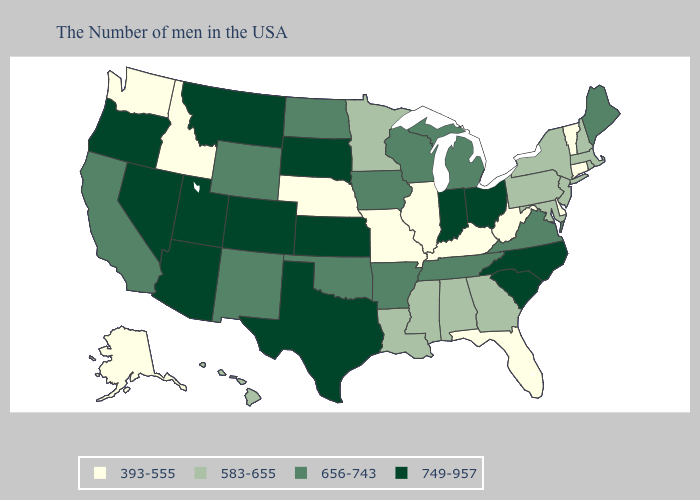How many symbols are there in the legend?
Quick response, please. 4. What is the lowest value in the Northeast?
Be succinct. 393-555. What is the value of South Dakota?
Write a very short answer. 749-957. Which states have the lowest value in the USA?
Concise answer only. Vermont, Connecticut, Delaware, West Virginia, Florida, Kentucky, Illinois, Missouri, Nebraska, Idaho, Washington, Alaska. Does Montana have the highest value in the USA?
Keep it brief. Yes. Does Pennsylvania have the highest value in the Northeast?
Write a very short answer. No. What is the highest value in states that border Georgia?
Short answer required. 749-957. Among the states that border North Carolina , does Georgia have the highest value?
Quick response, please. No. What is the highest value in the USA?
Answer briefly. 749-957. What is the lowest value in the MidWest?
Keep it brief. 393-555. Name the states that have a value in the range 393-555?
Short answer required. Vermont, Connecticut, Delaware, West Virginia, Florida, Kentucky, Illinois, Missouri, Nebraska, Idaho, Washington, Alaska. Name the states that have a value in the range 583-655?
Write a very short answer. Massachusetts, Rhode Island, New Hampshire, New York, New Jersey, Maryland, Pennsylvania, Georgia, Alabama, Mississippi, Louisiana, Minnesota, Hawaii. What is the highest value in states that border Idaho?
Quick response, please. 749-957. What is the value of Connecticut?
Concise answer only. 393-555. 